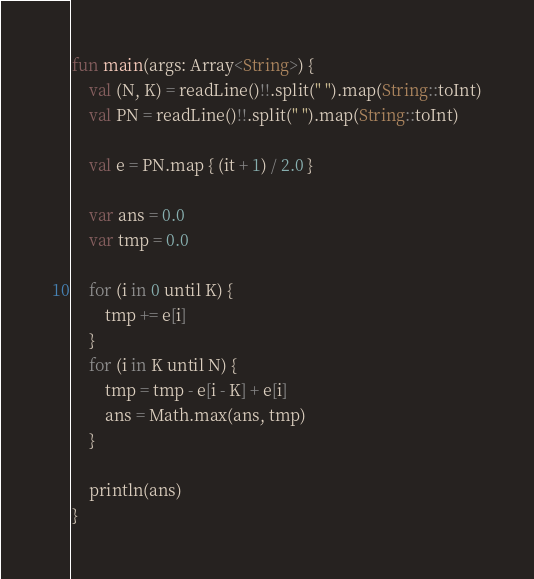Convert code to text. <code><loc_0><loc_0><loc_500><loc_500><_Kotlin_>fun main(args: Array<String>) {
    val (N, K) = readLine()!!.split(" ").map(String::toInt)
    val PN = readLine()!!.split(" ").map(String::toInt)

    val e = PN.map { (it + 1) / 2.0 }

    var ans = 0.0
    var tmp = 0.0

    for (i in 0 until K) {
        tmp += e[i]
    }
    for (i in K until N) {
        tmp = tmp - e[i - K] + e[i]
        ans = Math.max(ans, tmp)
    }

    println(ans)
}

</code> 